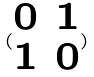<formula> <loc_0><loc_0><loc_500><loc_500>( \begin{matrix} 0 & 1 \\ 1 & 0 \end{matrix} )</formula> 